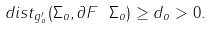<formula> <loc_0><loc_0><loc_500><loc_500>d i s t _ { g _ { o } ^ { \prime } } ( \Sigma _ { o } , \partial F \ \Sigma _ { o } ) \geq d _ { o } > 0 .</formula> 